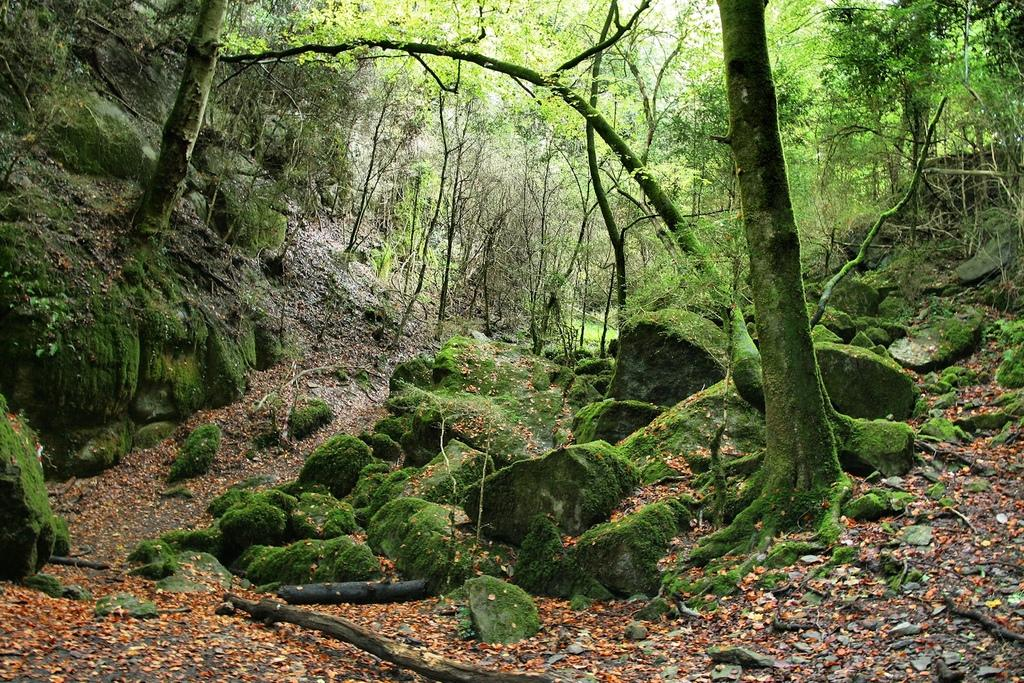What type of vegetation is present in the image? There is a group of trees in the image. What can be seen on the ground in the image? Stones are placed on the ground in the image. What is the opinion of the trees about the stones in the image? Trees do not have opinions, as they are inanimate objects. 